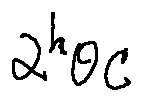<formula> <loc_0><loc_0><loc_500><loc_500>\alpha ^ { h } \theta C</formula> 